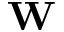Convert formula to latex. <formula><loc_0><loc_0><loc_500><loc_500>{ W }</formula> 